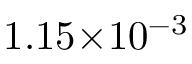<formula> <loc_0><loc_0><loc_500><loc_500>1 . 1 5 { \times } 1 0 ^ { - 3 }</formula> 